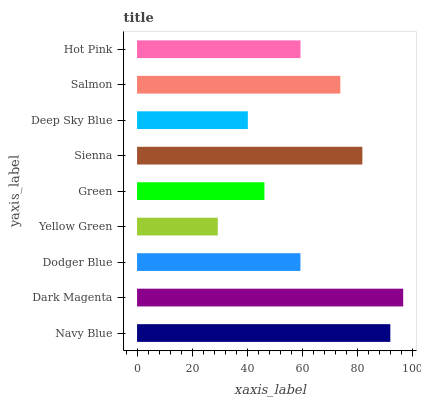Is Yellow Green the minimum?
Answer yes or no. Yes. Is Dark Magenta the maximum?
Answer yes or no. Yes. Is Dodger Blue the minimum?
Answer yes or no. No. Is Dodger Blue the maximum?
Answer yes or no. No. Is Dark Magenta greater than Dodger Blue?
Answer yes or no. Yes. Is Dodger Blue less than Dark Magenta?
Answer yes or no. Yes. Is Dodger Blue greater than Dark Magenta?
Answer yes or no. No. Is Dark Magenta less than Dodger Blue?
Answer yes or no. No. Is Hot Pink the high median?
Answer yes or no. Yes. Is Hot Pink the low median?
Answer yes or no. Yes. Is Green the high median?
Answer yes or no. No. Is Green the low median?
Answer yes or no. No. 